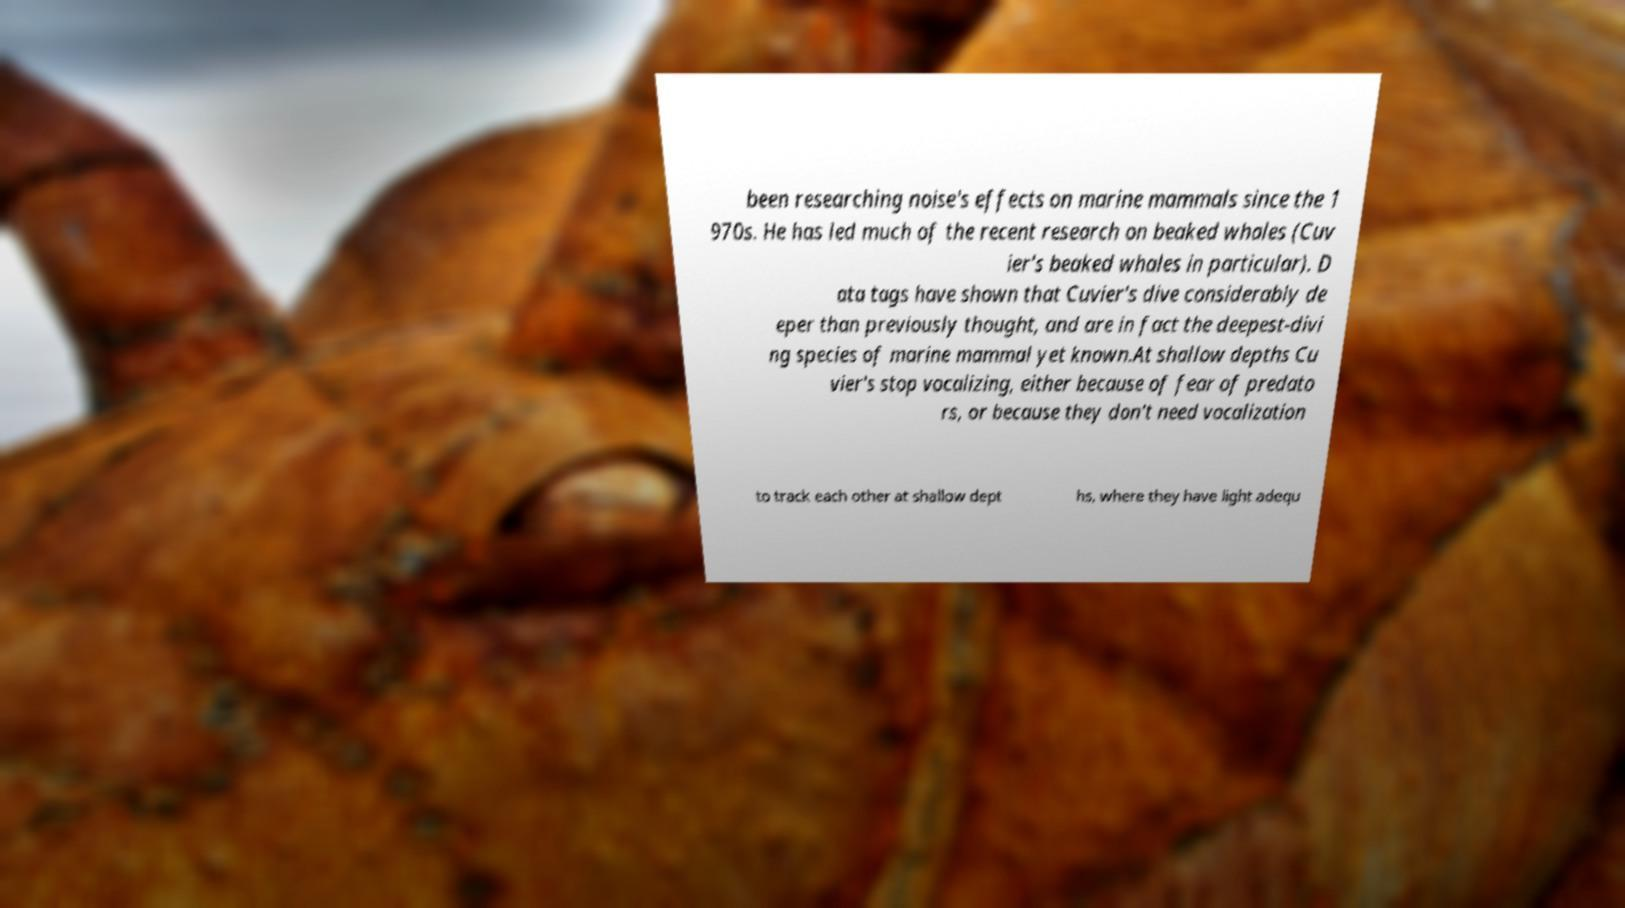Can you read and provide the text displayed in the image?This photo seems to have some interesting text. Can you extract and type it out for me? been researching noise's effects on marine mammals since the 1 970s. He has led much of the recent research on beaked whales (Cuv ier's beaked whales in particular). D ata tags have shown that Cuvier's dive considerably de eper than previously thought, and are in fact the deepest-divi ng species of marine mammal yet known.At shallow depths Cu vier's stop vocalizing, either because of fear of predato rs, or because they don't need vocalization to track each other at shallow dept hs, where they have light adequ 